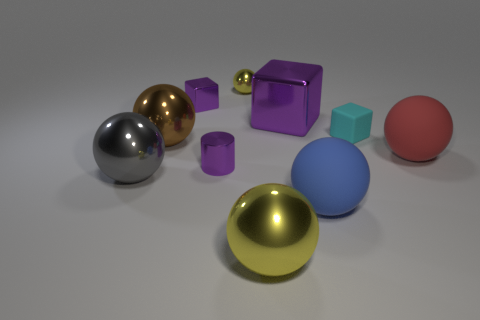There is a purple metallic thing on the right side of the large yellow ball; what shape is it?
Offer a terse response. Cube. Do the tiny thing that is to the right of the big yellow object and the yellow object that is behind the red rubber object have the same shape?
Keep it short and to the point. No. Is the number of red matte balls that are left of the big yellow metal thing the same as the number of gray metallic balls?
Provide a succinct answer. No. There is a large blue object that is the same shape as the gray metal object; what is its material?
Keep it short and to the point. Rubber. What shape is the yellow thing that is right of the yellow object that is behind the large block?
Your response must be concise. Sphere. Does the sphere that is behind the cyan matte object have the same material as the brown sphere?
Ensure brevity in your answer.  Yes. Are there an equal number of purple objects behind the tiny yellow thing and tiny purple metallic blocks that are right of the big blue thing?
Your response must be concise. Yes. How many tiny purple metallic cylinders are behind the rubber sphere left of the big red object?
Offer a very short reply. 1. Does the big matte sphere behind the cylinder have the same color as the metal object that is in front of the blue ball?
Offer a terse response. No. What is the material of the block that is the same size as the cyan object?
Offer a very short reply. Metal. 